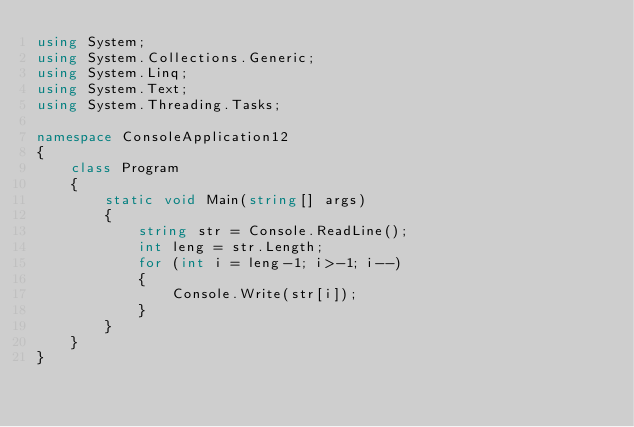Convert code to text. <code><loc_0><loc_0><loc_500><loc_500><_C#_>using System;
using System.Collections.Generic;
using System.Linq;
using System.Text;
using System.Threading.Tasks;

namespace ConsoleApplication12
{
    class Program
    {
        static void Main(string[] args)
        {
            string str = Console.ReadLine();
            int leng = str.Length;
            for (int i = leng-1; i>-1; i--)
            {
                Console.Write(str[i]);
            }
        }
    }
}</code> 